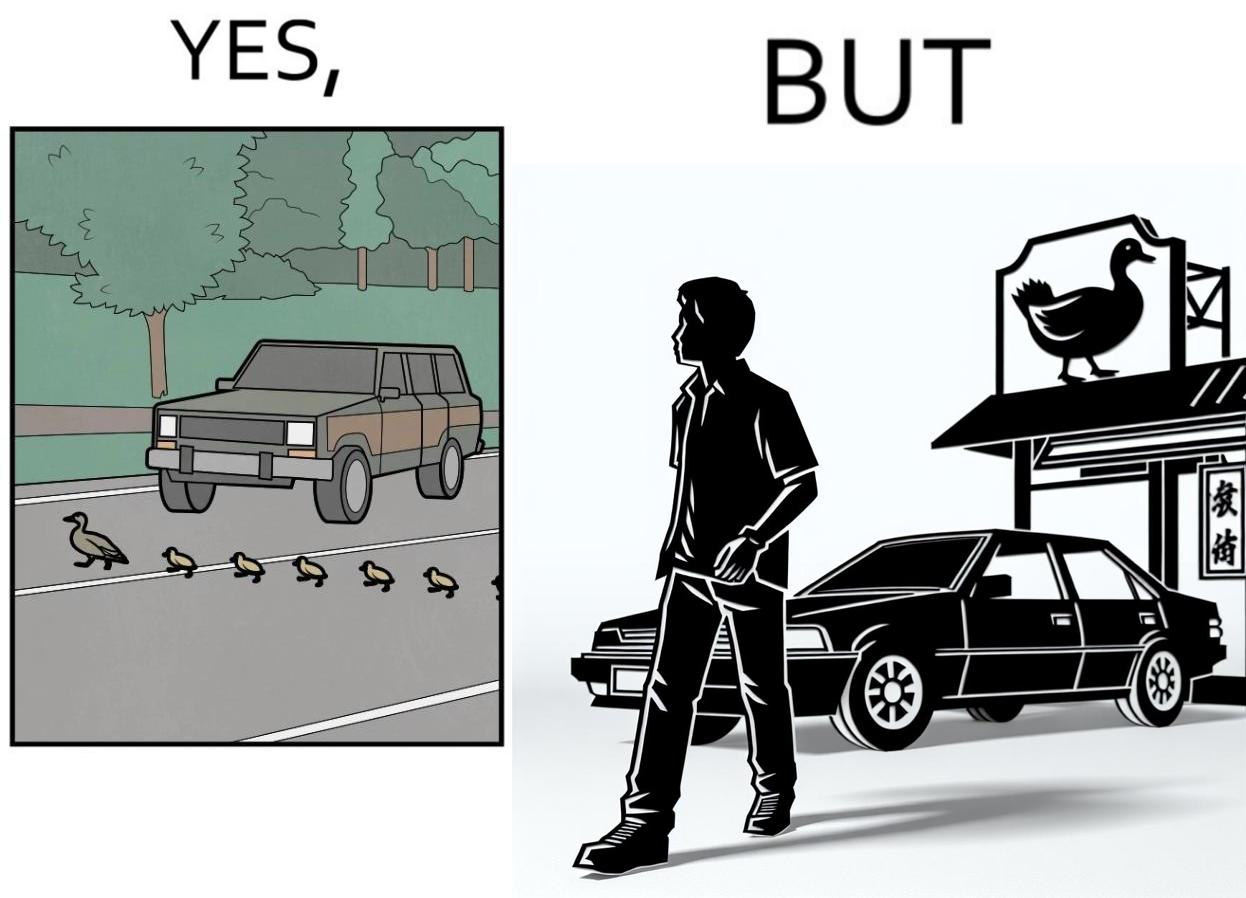What is shown in this image? The images are ironic since they show how a man supposedly cares for ducks since he stops his vehicle to give way to queue of ducks allowing them to safely cross a road but on the other hand he goes to a peking duck shop to buy and eat similar ducks after having them killed 